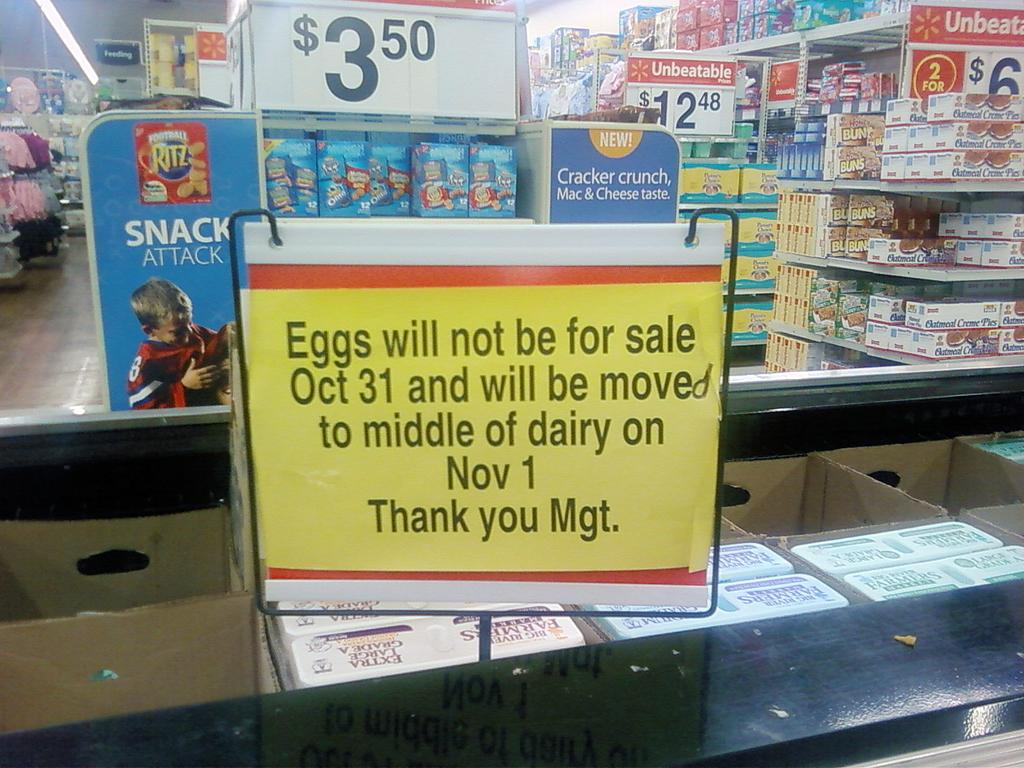Provide a one-sentence caption for the provided image. A grocery store with a sign that reads Eggs will not be for sale Oct 31. 